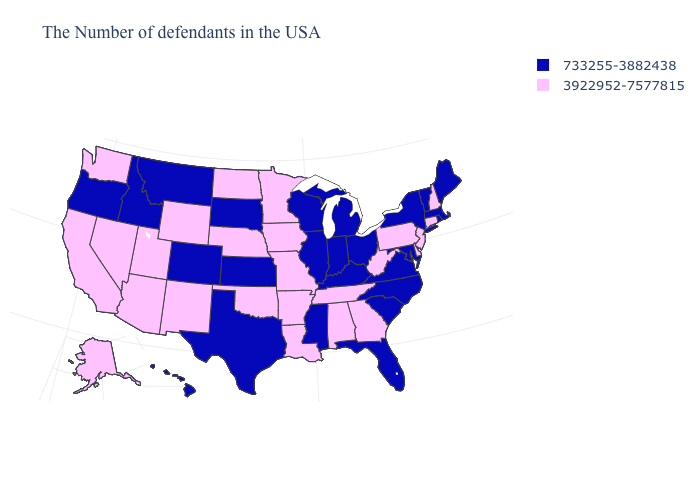What is the value of Oklahoma?
Be succinct. 3922952-7577815. What is the lowest value in the USA?
Be succinct. 733255-3882438. Name the states that have a value in the range 733255-3882438?
Be succinct. Maine, Massachusetts, Rhode Island, Vermont, New York, Maryland, Virginia, North Carolina, South Carolina, Ohio, Florida, Michigan, Kentucky, Indiana, Wisconsin, Illinois, Mississippi, Kansas, Texas, South Dakota, Colorado, Montana, Idaho, Oregon, Hawaii. What is the lowest value in states that border Iowa?
Give a very brief answer. 733255-3882438. Name the states that have a value in the range 733255-3882438?
Answer briefly. Maine, Massachusetts, Rhode Island, Vermont, New York, Maryland, Virginia, North Carolina, South Carolina, Ohio, Florida, Michigan, Kentucky, Indiana, Wisconsin, Illinois, Mississippi, Kansas, Texas, South Dakota, Colorado, Montana, Idaho, Oregon, Hawaii. What is the value of New York?
Give a very brief answer. 733255-3882438. What is the lowest value in the MidWest?
Give a very brief answer. 733255-3882438. Does Colorado have the same value as Kentucky?
Give a very brief answer. Yes. Does Vermont have the lowest value in the USA?
Quick response, please. Yes. What is the value of Maine?
Short answer required. 733255-3882438. Name the states that have a value in the range 3922952-7577815?
Quick response, please. New Hampshire, Connecticut, New Jersey, Delaware, Pennsylvania, West Virginia, Georgia, Alabama, Tennessee, Louisiana, Missouri, Arkansas, Minnesota, Iowa, Nebraska, Oklahoma, North Dakota, Wyoming, New Mexico, Utah, Arizona, Nevada, California, Washington, Alaska. Does California have the lowest value in the West?
Give a very brief answer. No. What is the value of Alaska?
Answer briefly. 3922952-7577815. Name the states that have a value in the range 3922952-7577815?
Give a very brief answer. New Hampshire, Connecticut, New Jersey, Delaware, Pennsylvania, West Virginia, Georgia, Alabama, Tennessee, Louisiana, Missouri, Arkansas, Minnesota, Iowa, Nebraska, Oklahoma, North Dakota, Wyoming, New Mexico, Utah, Arizona, Nevada, California, Washington, Alaska. What is the lowest value in the Northeast?
Keep it brief. 733255-3882438. 